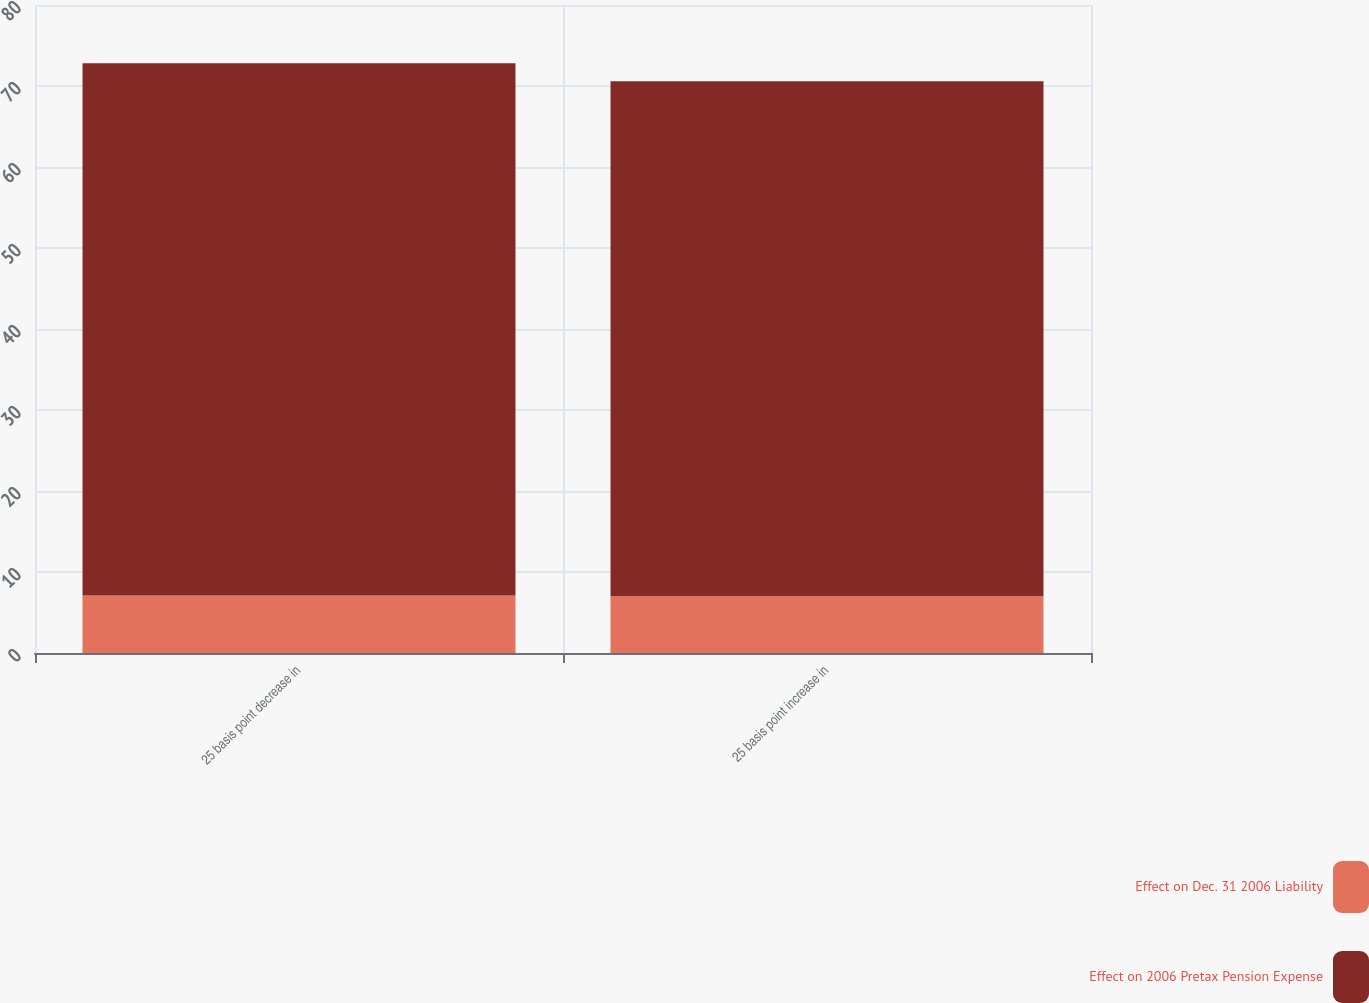Convert chart. <chart><loc_0><loc_0><loc_500><loc_500><stacked_bar_chart><ecel><fcel>25 basis point decrease in<fcel>25 basis point increase in<nl><fcel>Effect on Dec. 31 2006 Liability<fcel>7.1<fcel>7<nl><fcel>Effect on 2006 Pretax Pension Expense<fcel>65.7<fcel>63.6<nl></chart> 